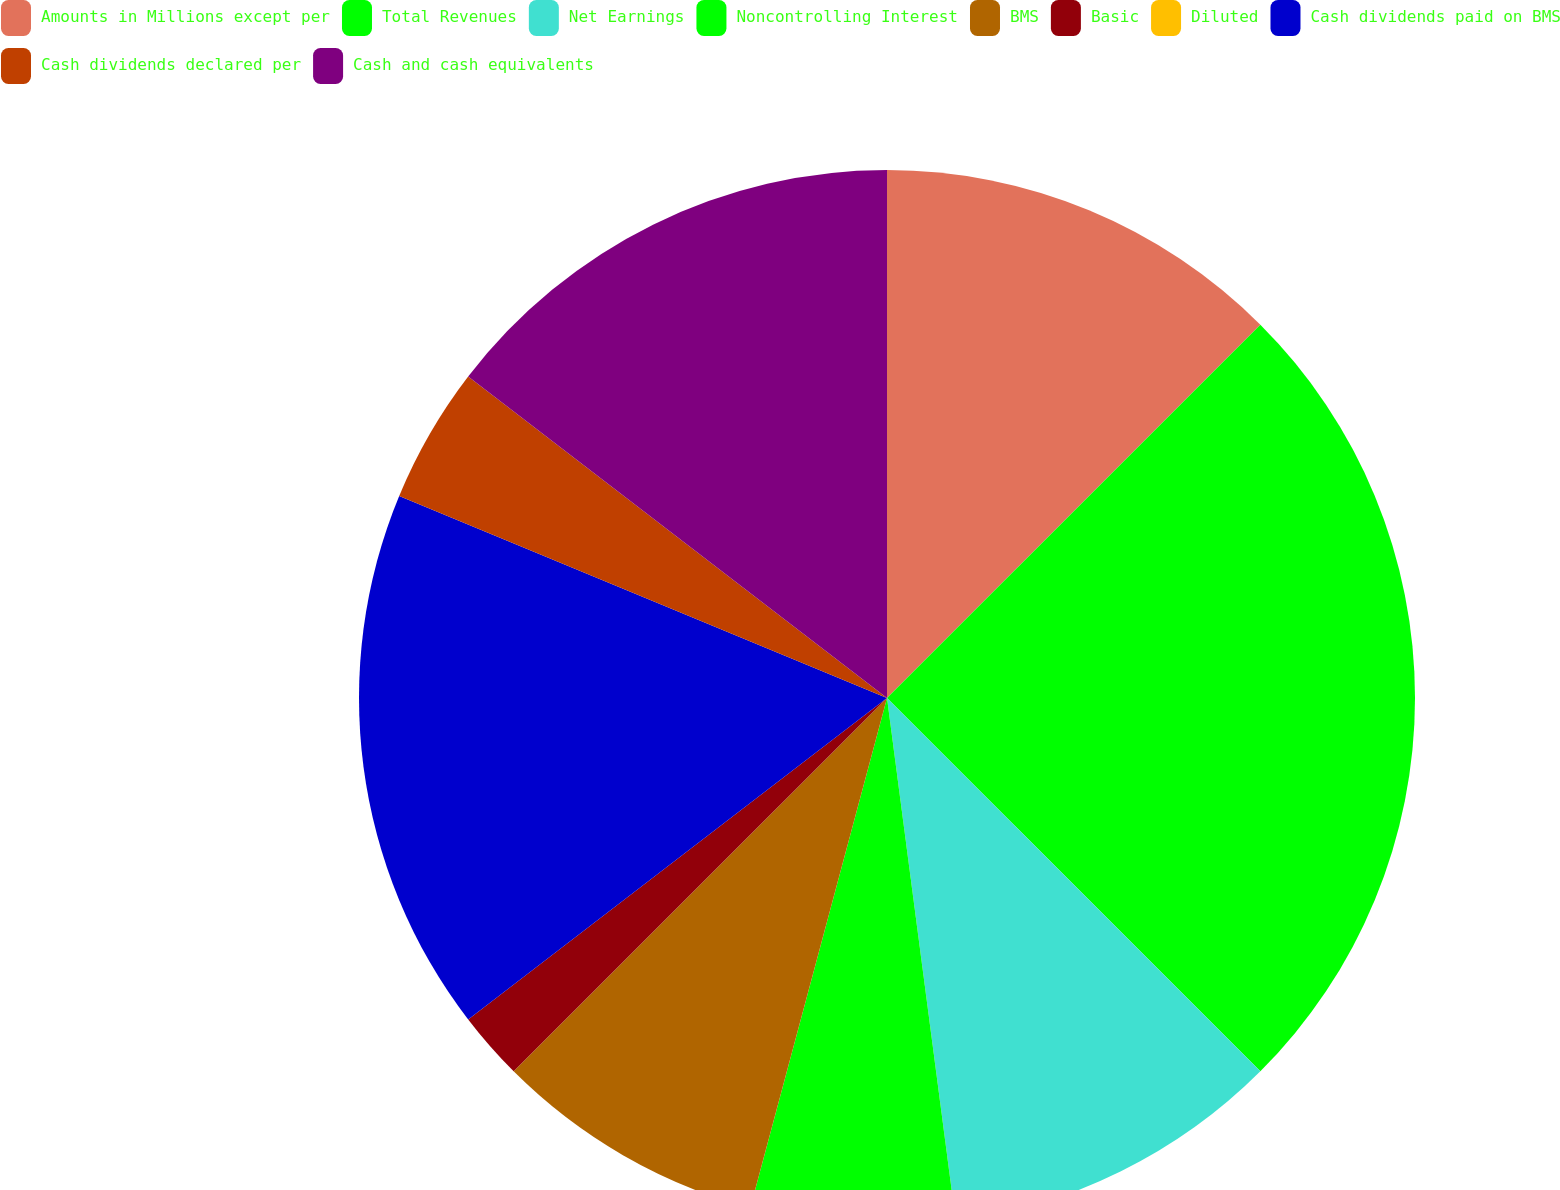<chart> <loc_0><loc_0><loc_500><loc_500><pie_chart><fcel>Amounts in Millions except per<fcel>Total Revenues<fcel>Net Earnings<fcel>Noncontrolling Interest<fcel>BMS<fcel>Basic<fcel>Diluted<fcel>Cash dividends paid on BMS<fcel>Cash dividends declared per<fcel>Cash and cash equivalents<nl><fcel>12.5%<fcel>25.0%<fcel>10.42%<fcel>6.25%<fcel>8.33%<fcel>2.08%<fcel>0.0%<fcel>16.67%<fcel>4.17%<fcel>14.58%<nl></chart> 